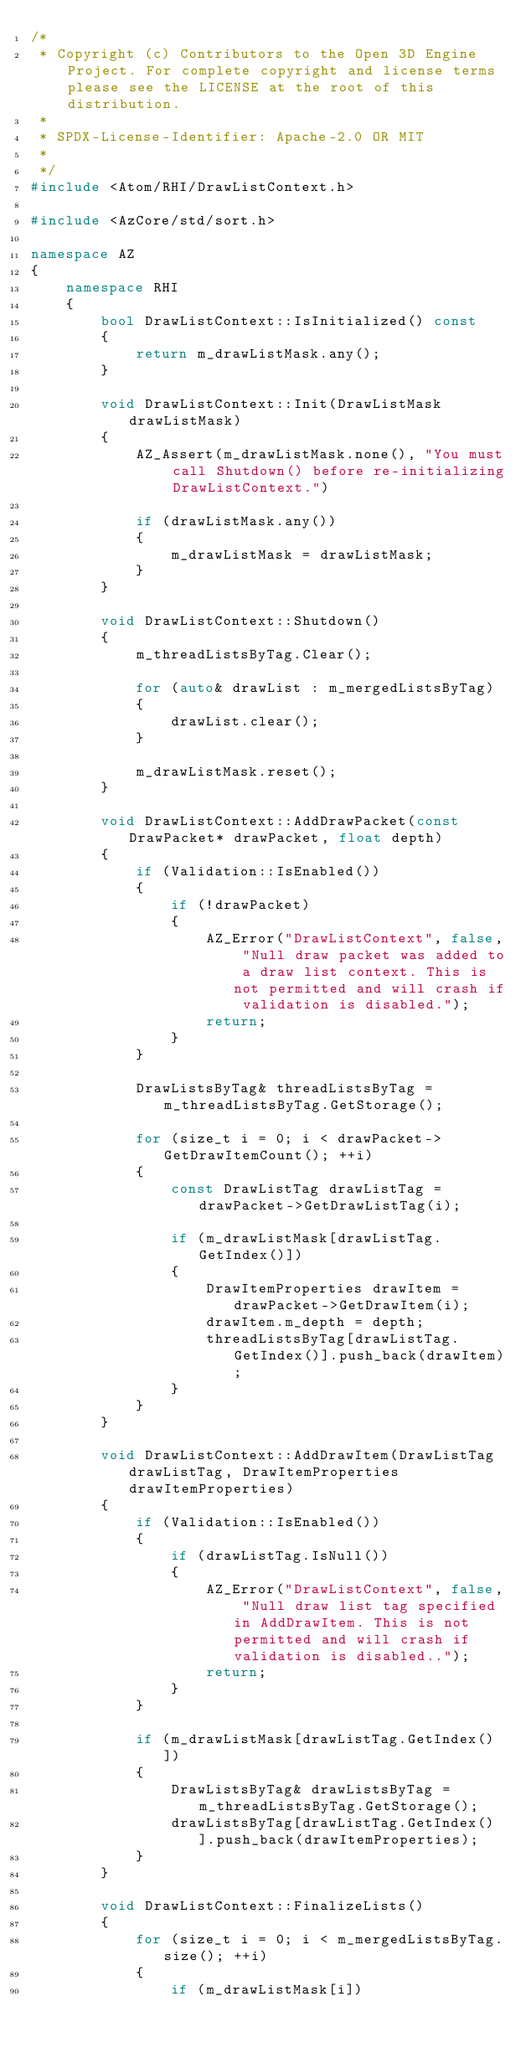<code> <loc_0><loc_0><loc_500><loc_500><_C++_>/*
 * Copyright (c) Contributors to the Open 3D Engine Project. For complete copyright and license terms please see the LICENSE at the root of this distribution.
 * 
 * SPDX-License-Identifier: Apache-2.0 OR MIT
 *
 */
#include <Atom/RHI/DrawListContext.h>

#include <AzCore/std/sort.h>

namespace AZ
{
    namespace RHI
    {
        bool DrawListContext::IsInitialized() const
        {
            return m_drawListMask.any();
        }

        void DrawListContext::Init(DrawListMask drawListMask)
        {
            AZ_Assert(m_drawListMask.none(), "You must call Shutdown() before re-initializing DrawListContext.")

            if (drawListMask.any())
            {
                m_drawListMask = drawListMask;
            }
        }

        void DrawListContext::Shutdown()
        {
            m_threadListsByTag.Clear();

            for (auto& drawList : m_mergedListsByTag)
            {
                drawList.clear();
            }

            m_drawListMask.reset();
        }

        void DrawListContext::AddDrawPacket(const DrawPacket* drawPacket, float depth)
        {
            if (Validation::IsEnabled())
            {
                if (!drawPacket)
                {
                    AZ_Error("DrawListContext", false, "Null draw packet was added to a draw list context. This is not permitted and will crash if validation is disabled.");
                    return;
                }
            }

            DrawListsByTag& threadListsByTag = m_threadListsByTag.GetStorage();

            for (size_t i = 0; i < drawPacket->GetDrawItemCount(); ++i)
            {
                const DrawListTag drawListTag = drawPacket->GetDrawListTag(i);

                if (m_drawListMask[drawListTag.GetIndex()])
                {
                    DrawItemProperties drawItem = drawPacket->GetDrawItem(i);
                    drawItem.m_depth = depth;
                    threadListsByTag[drawListTag.GetIndex()].push_back(drawItem);
                }
            }
        }

        void DrawListContext::AddDrawItem(DrawListTag drawListTag, DrawItemProperties drawItemProperties)
        {
            if (Validation::IsEnabled())
            {
                if (drawListTag.IsNull())
                {
                    AZ_Error("DrawListContext", false, "Null draw list tag specified in AddDrawItem. This is not permitted and will crash if validation is disabled..");
                    return;
                }
            }

            if (m_drawListMask[drawListTag.GetIndex()])
            {
                DrawListsByTag& drawListsByTag = m_threadListsByTag.GetStorage();
                drawListsByTag[drawListTag.GetIndex()].push_back(drawItemProperties);
            }
        }

        void DrawListContext::FinalizeLists()
        {
            for (size_t i = 0; i < m_mergedListsByTag.size(); ++i)
            {
                if (m_drawListMask[i])</code> 